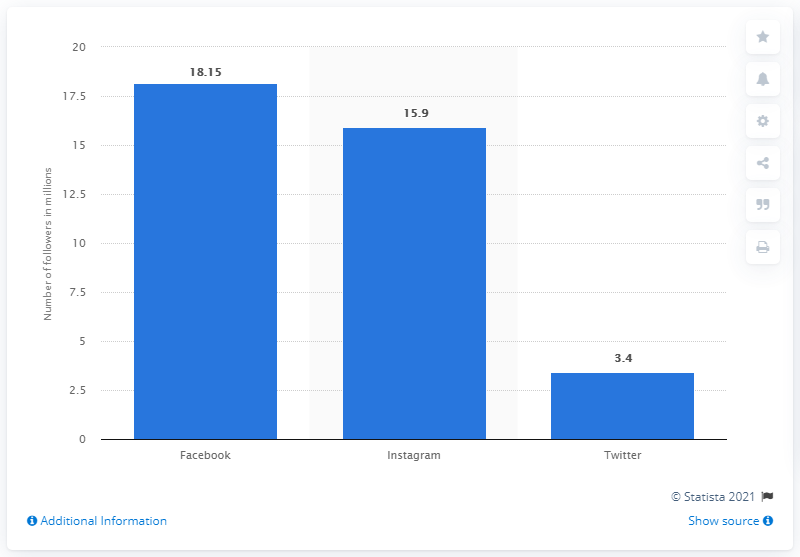Mention a couple of crucial points in this snapshot. As of March 2021, Michael Kors had 18.15 followers on Facebook. As of March 2021, Michael Kors had 3.4 million followers on Twitter. 